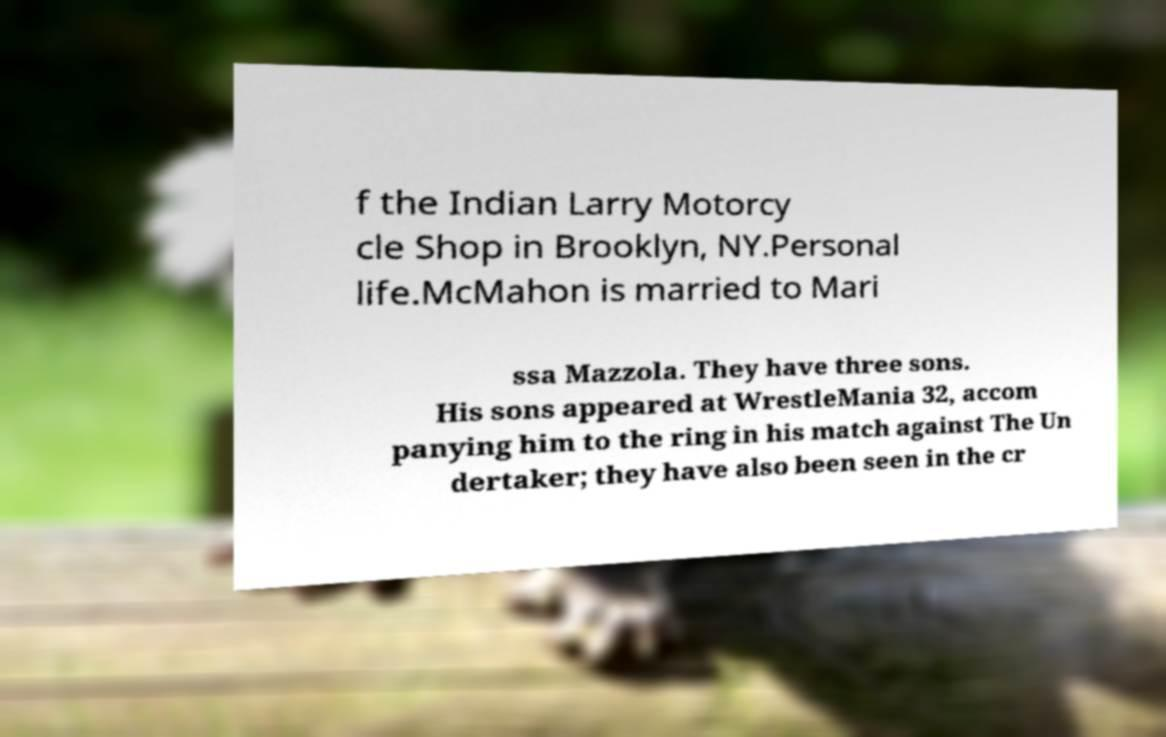Could you extract and type out the text from this image? f the Indian Larry Motorcy cle Shop in Brooklyn, NY.Personal life.McMahon is married to Mari ssa Mazzola. They have three sons. His sons appeared at WrestleMania 32, accom panying him to the ring in his match against The Un dertaker; they have also been seen in the cr 